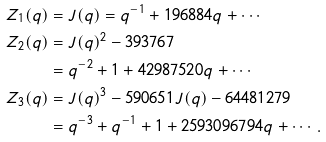<formula> <loc_0><loc_0><loc_500><loc_500>Z _ { 1 } ( q ) & = J ( q ) = q ^ { - 1 } + 1 9 6 8 8 4 q + \cdots \\ Z _ { 2 } ( q ) & = J ( q ) ^ { 2 } - 3 9 3 7 6 7 \\ & = q ^ { - 2 } + 1 + 4 2 9 8 7 5 2 0 q + \cdots \\ Z _ { 3 } ( q ) & = J ( q ) ^ { 3 } - 5 9 0 6 5 1 J ( q ) - 6 4 4 8 1 2 7 9 \\ & = q ^ { - 3 } + q ^ { - 1 } + 1 + 2 5 9 3 0 9 6 7 9 4 q + \cdots .</formula> 